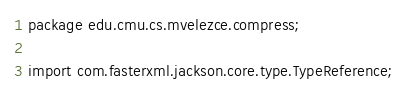<code> <loc_0><loc_0><loc_500><loc_500><_Java_>package edu.cmu.cs.mvelezce.compress;

import com.fasterxml.jackson.core.type.TypeReference;</code> 